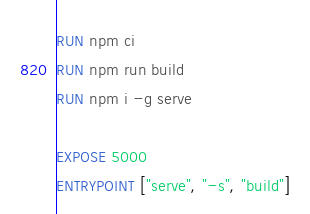<code> <loc_0><loc_0><loc_500><loc_500><_Dockerfile_>
RUN npm ci
RUN npm run build
RUN npm i -g serve

EXPOSE 5000
ENTRYPOINT ["serve", "-s", "build"]</code> 